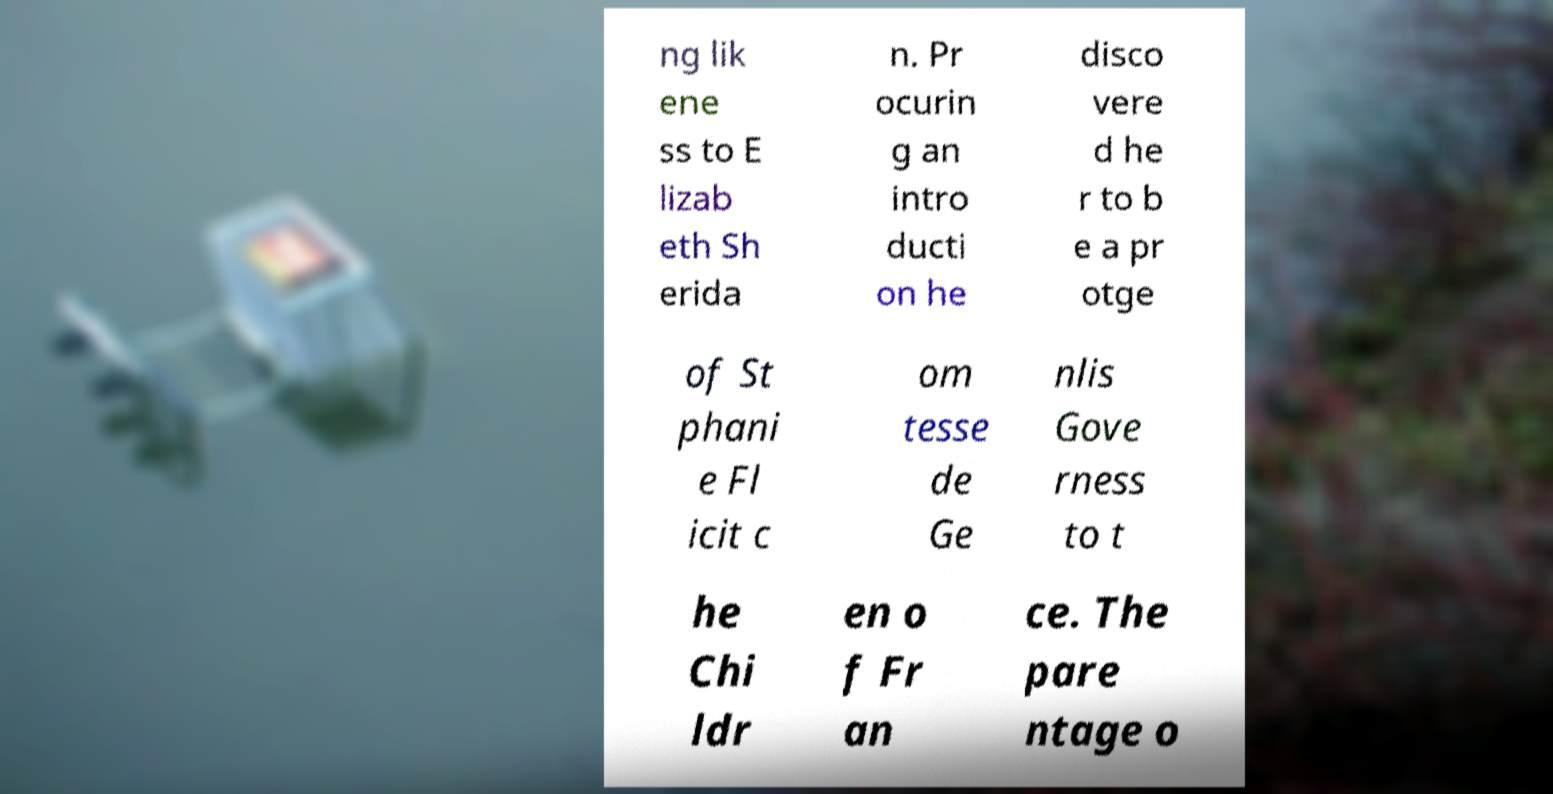Please read and relay the text visible in this image. What does it say? ng lik ene ss to E lizab eth Sh erida n. Pr ocurin g an intro ducti on he disco vere d he r to b e a pr otge of St phani e Fl icit c om tesse de Ge nlis Gove rness to t he Chi ldr en o f Fr an ce. The pare ntage o 